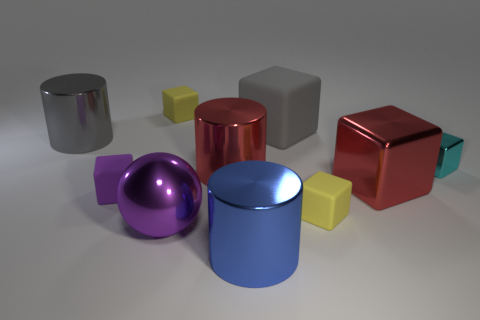What mood does this arrangement of objects convey to you? The image has a clean and orderly aesthetic, perhaps conveying a sense of calmness and organization. The various colors might introduce a playful element, although the muted background keeps the overall atmosphere subdued. 